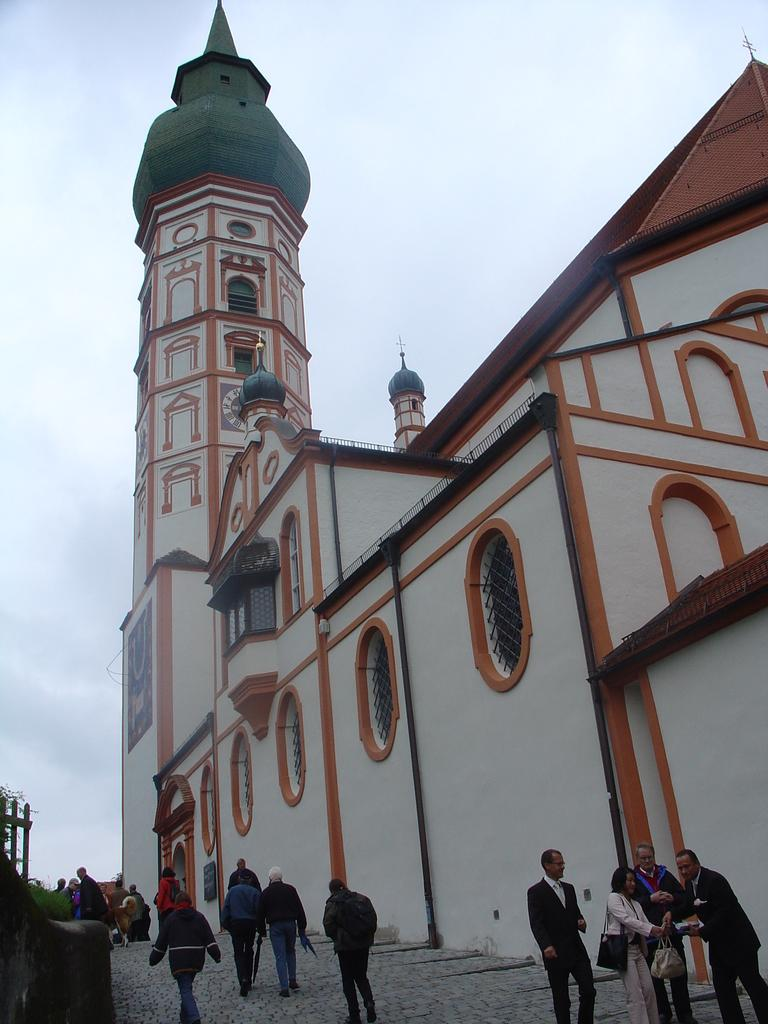What type of structure is present in the image? There is a building in the image. What can be seen in the image besides the building? There is a path in the image. Are there any people visible in the image? Yes, there are people on the path in the image. What type of zebra can be seen exchanging a can with one of the people in the image? There is no zebra or exchange of a can present in the image. 